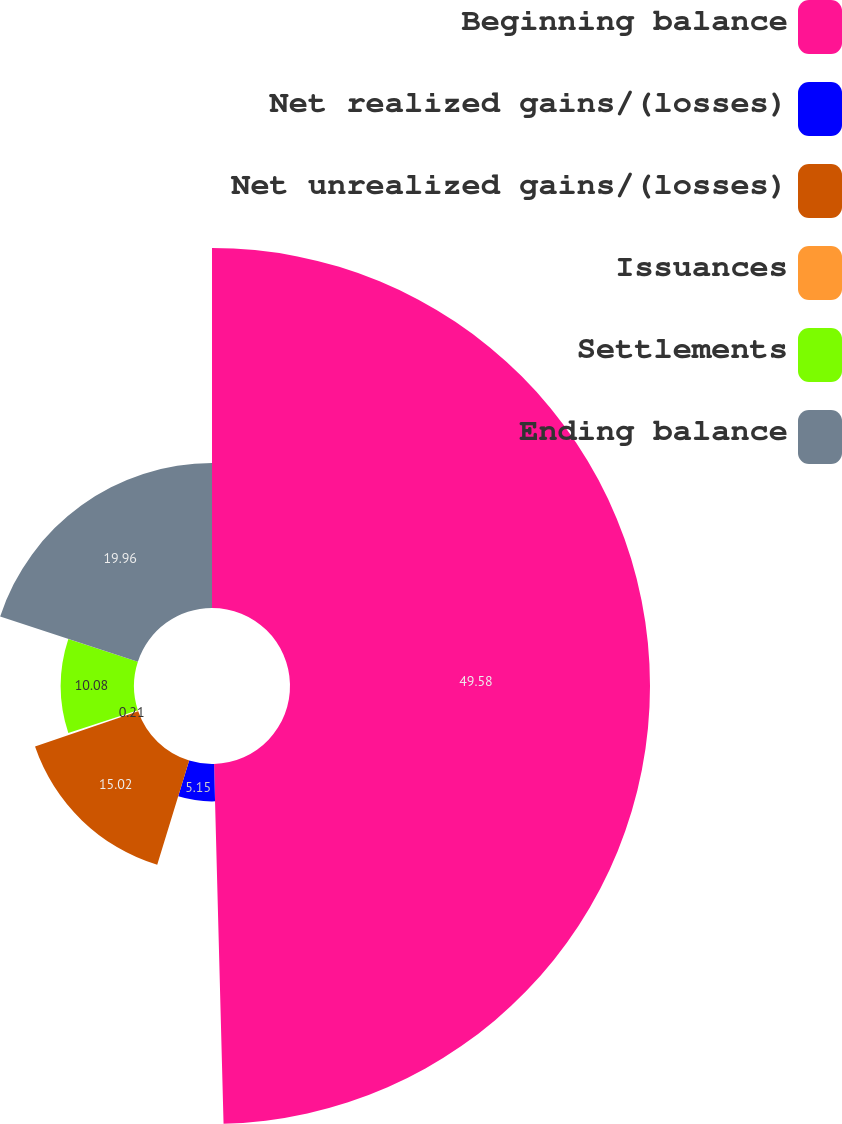Convert chart. <chart><loc_0><loc_0><loc_500><loc_500><pie_chart><fcel>Beginning balance<fcel>Net realized gains/(losses)<fcel>Net unrealized gains/(losses)<fcel>Issuances<fcel>Settlements<fcel>Ending balance<nl><fcel>49.58%<fcel>5.15%<fcel>15.02%<fcel>0.21%<fcel>10.08%<fcel>19.96%<nl></chart> 